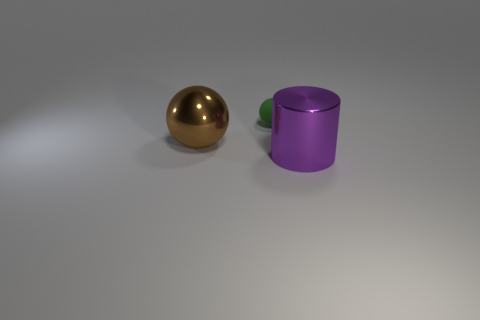Add 2 large brown balls. How many objects exist? 5 Subtract all cylinders. How many objects are left? 2 Add 3 green rubber spheres. How many green rubber spheres exist? 4 Subtract 0 yellow spheres. How many objects are left? 3 Subtract all metallic cylinders. Subtract all brown metal balls. How many objects are left? 1 Add 2 large metal cylinders. How many large metal cylinders are left? 3 